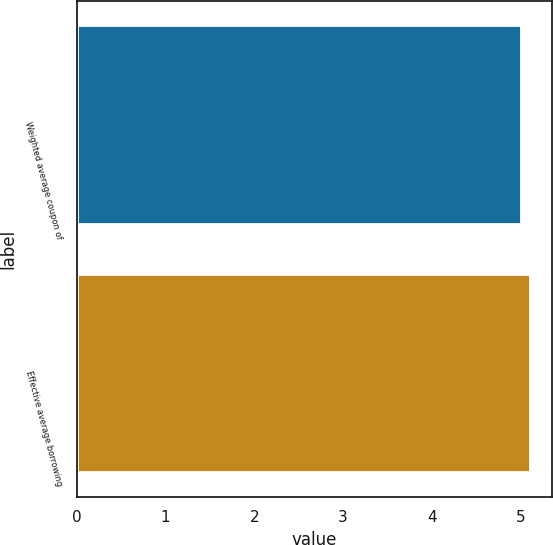<chart> <loc_0><loc_0><loc_500><loc_500><bar_chart><fcel>Weighted average coupon of<fcel>Effective average borrowing<nl><fcel>5<fcel>5.1<nl></chart> 